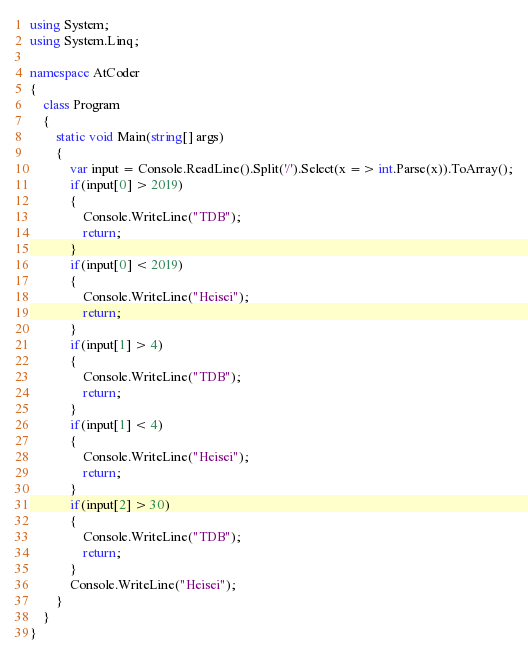<code> <loc_0><loc_0><loc_500><loc_500><_C#_>using System;
using System.Linq;

namespace AtCoder
{
    class Program
    {
        static void Main(string[] args)
        {
            var input = Console.ReadLine().Split('/').Select(x => int.Parse(x)).ToArray();
            if(input[0] > 2019)
            {
                Console.WriteLine("TDB");
                return;
            }
            if(input[0] < 2019)
            {
                Console.WriteLine("Heisei");
                return;
            }
            if(input[1] > 4)
            {
                Console.WriteLine("TDB");
                return;
            }
            if(input[1] < 4)
            {
                Console.WriteLine("Heisei");
                return;
            }
            if(input[2] > 30)
            {
                Console.WriteLine("TDB");
                return;
            }
            Console.WriteLine("Heisei");
        }
    }
}
</code> 